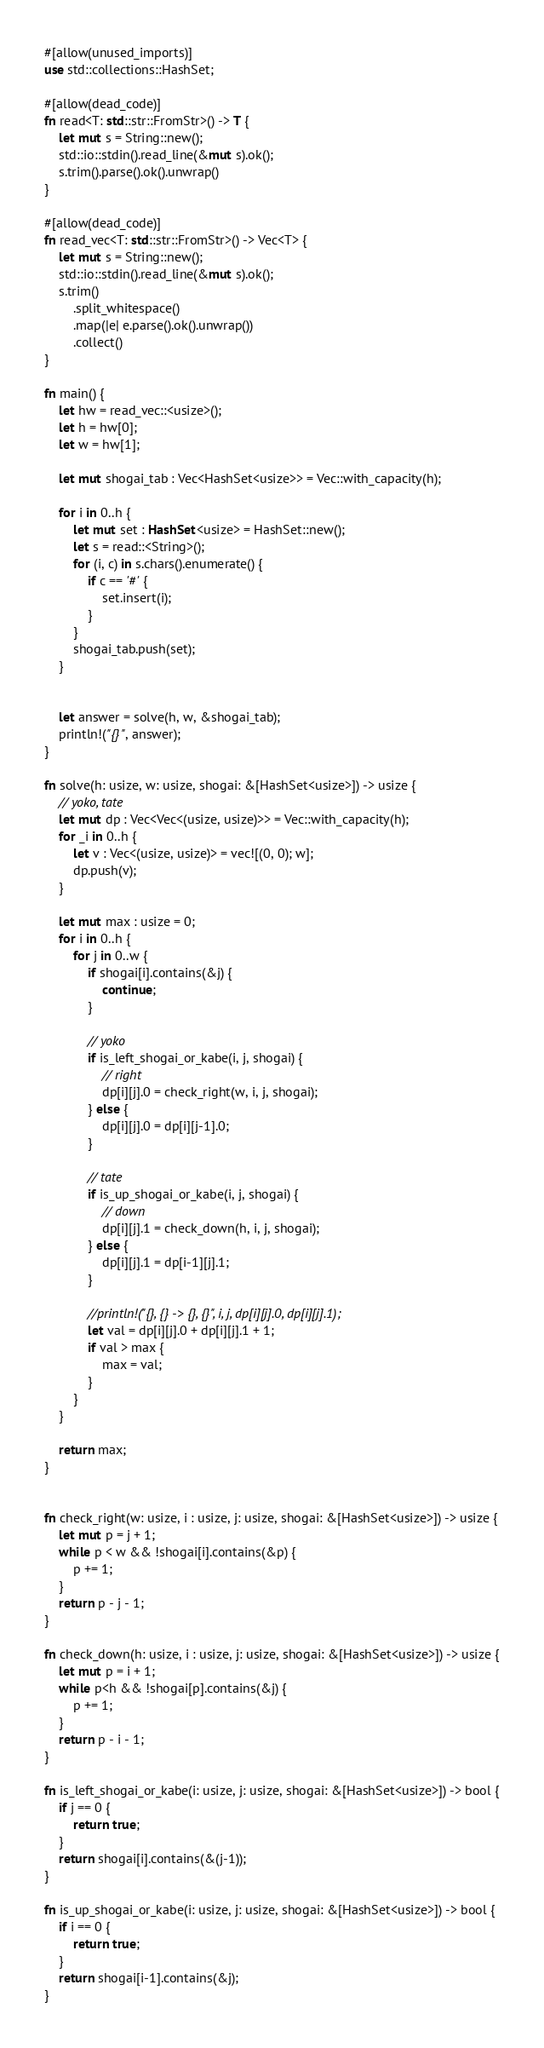<code> <loc_0><loc_0><loc_500><loc_500><_Rust_>#[allow(unused_imports)]
use std::collections::HashSet;

#[allow(dead_code)]
fn read<T: std::str::FromStr>() -> T {
    let mut s = String::new();
    std::io::stdin().read_line(&mut s).ok();
    s.trim().parse().ok().unwrap()
}

#[allow(dead_code)]
fn read_vec<T: std::str::FromStr>() -> Vec<T> {
    let mut s = String::new();
    std::io::stdin().read_line(&mut s).ok();
    s.trim()
        .split_whitespace()
        .map(|e| e.parse().ok().unwrap())
        .collect()
}

fn main() {
    let hw = read_vec::<usize>();
    let h = hw[0];
    let w = hw[1];

    let mut shogai_tab : Vec<HashSet<usize>> = Vec::with_capacity(h);
    
    for i in 0..h {
        let mut set : HashSet<usize> = HashSet::new();
        let s = read::<String>();
        for (i, c) in s.chars().enumerate() {
            if c == '#' {
                set.insert(i);
            }
        }
        shogai_tab.push(set);
    }


    let answer = solve(h, w, &shogai_tab);
    println!("{}", answer);
}

fn solve(h: usize, w: usize, shogai: &[HashSet<usize>]) -> usize {
    // yoko, tate
    let mut dp : Vec<Vec<(usize, usize)>> = Vec::with_capacity(h);
    for _i in 0..h {
        let v : Vec<(usize, usize)> = vec![(0, 0); w];
        dp.push(v);
    }

    let mut max : usize = 0;
    for i in 0..h {
        for j in 0..w {
            if shogai[i].contains(&j) {
                continue;
            }

            // yoko
            if is_left_shogai_or_kabe(i, j, shogai) {
                // right
                dp[i][j].0 = check_right(w, i, j, shogai);
            } else {
                dp[i][j].0 = dp[i][j-1].0;
            }

            // tate
            if is_up_shogai_or_kabe(i, j, shogai) {
                // down
                dp[i][j].1 = check_down(h, i, j, shogai);
            } else {
                dp[i][j].1 = dp[i-1][j].1;
            }

            //println!("{}, {} -> {}, {}", i, j, dp[i][j].0, dp[i][j].1);
            let val = dp[i][j].0 + dp[i][j].1 + 1;
            if val > max {
                max = val;
            }
        }
    }

    return max;
}


fn check_right(w: usize, i : usize, j: usize, shogai: &[HashSet<usize>]) -> usize {
    let mut p = j + 1;
    while p < w && !shogai[i].contains(&p) {
        p += 1;
    }
    return p - j - 1;
}

fn check_down(h: usize, i : usize, j: usize, shogai: &[HashSet<usize>]) -> usize {
    let mut p = i + 1;
    while p<h && !shogai[p].contains(&j) {
        p += 1;
    }
    return p - i - 1;
}

fn is_left_shogai_or_kabe(i: usize, j: usize, shogai: &[HashSet<usize>]) -> bool {
    if j == 0 {
        return true;
    }
    return shogai[i].contains(&(j-1));
}

fn is_up_shogai_or_kabe(i: usize, j: usize, shogai: &[HashSet<usize>]) -> bool {
    if i == 0 {
        return true;
    }
    return shogai[i-1].contains(&j);
}</code> 